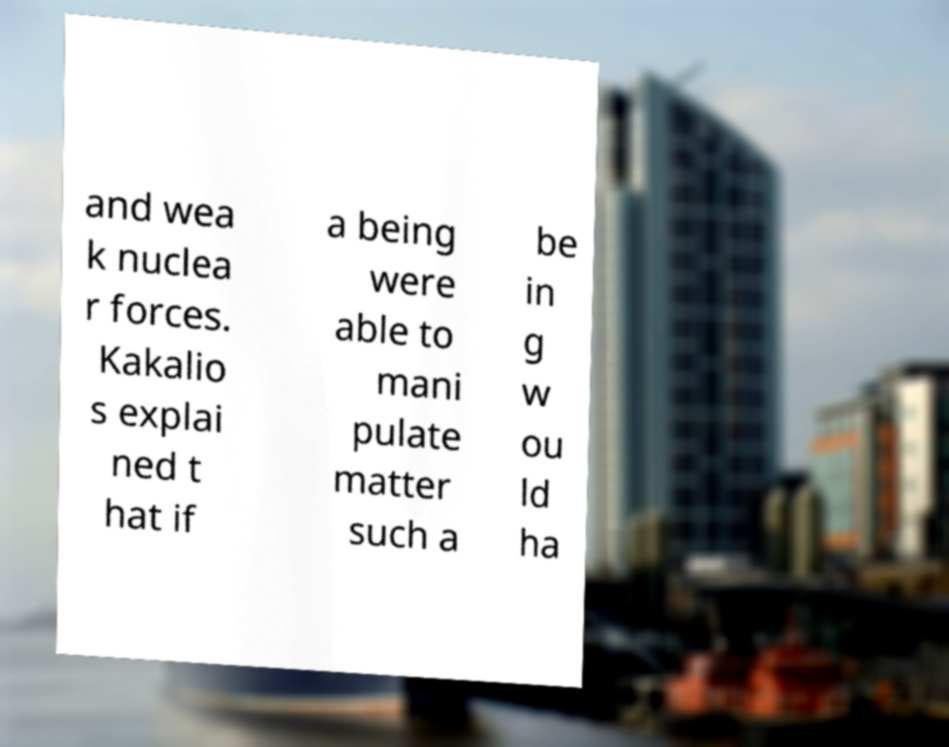For documentation purposes, I need the text within this image transcribed. Could you provide that? and wea k nuclea r forces. Kakalio s explai ned t hat if a being were able to mani pulate matter such a be in g w ou ld ha 